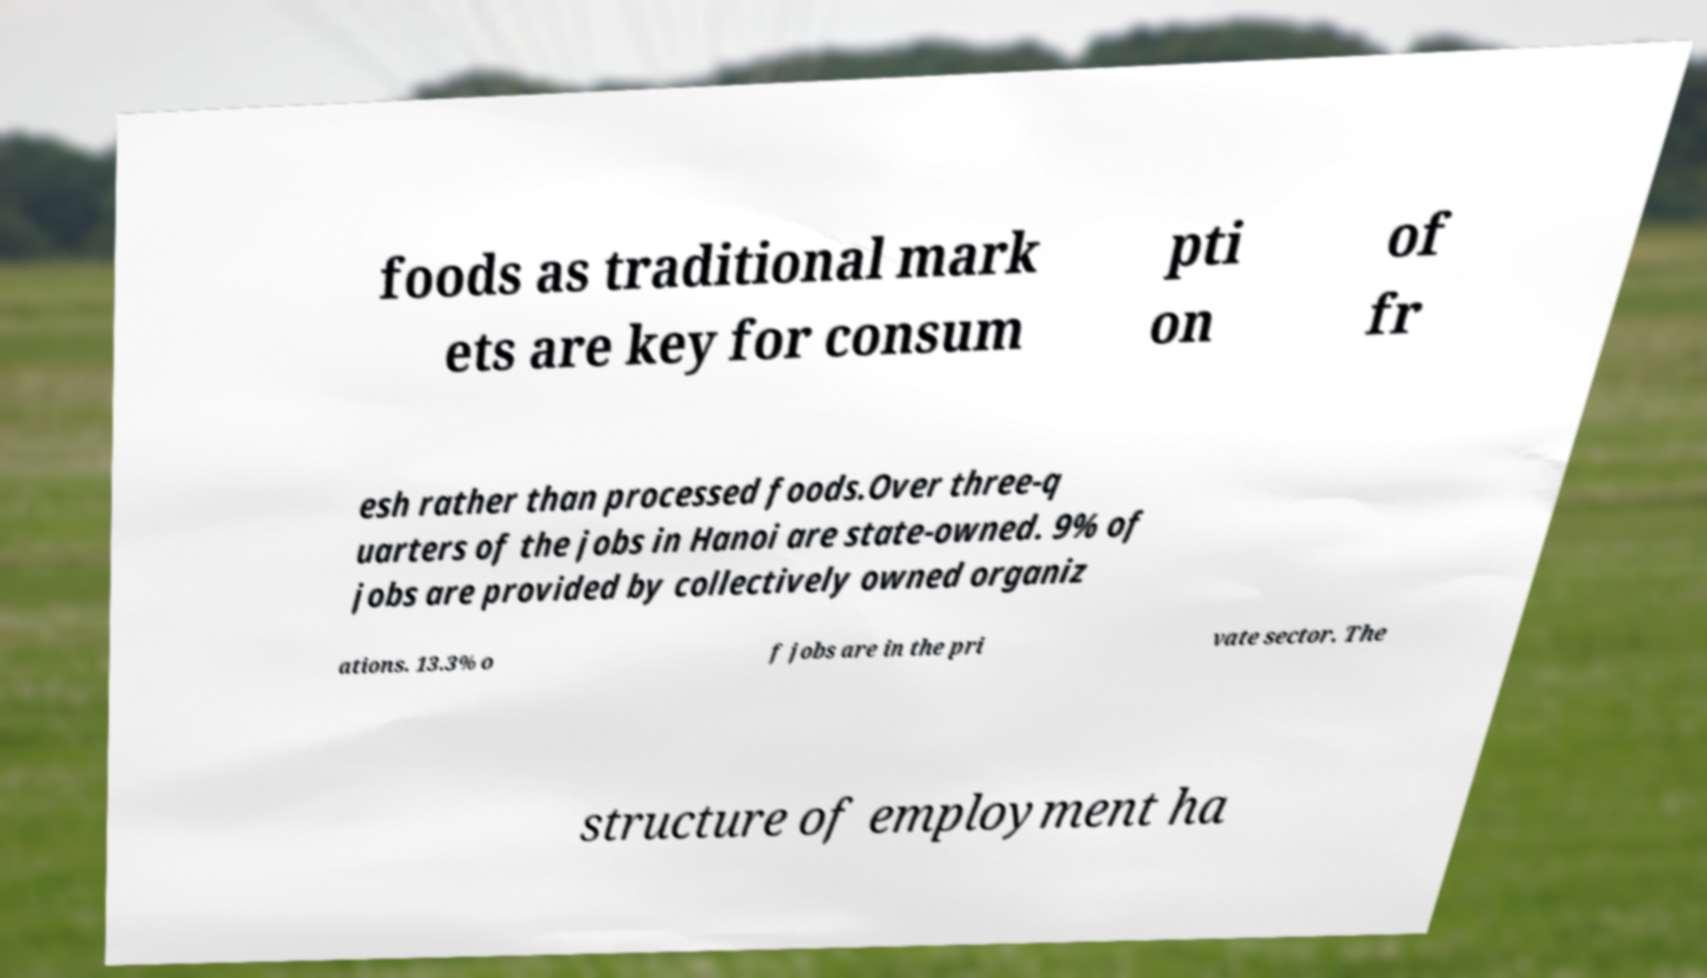Please read and relay the text visible in this image. What does it say? foods as traditional mark ets are key for consum pti on of fr esh rather than processed foods.Over three-q uarters of the jobs in Hanoi are state-owned. 9% of jobs are provided by collectively owned organiz ations. 13.3% o f jobs are in the pri vate sector. The structure of employment ha 